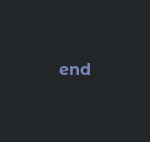<code> <loc_0><loc_0><loc_500><loc_500><_Ruby_>end
</code> 